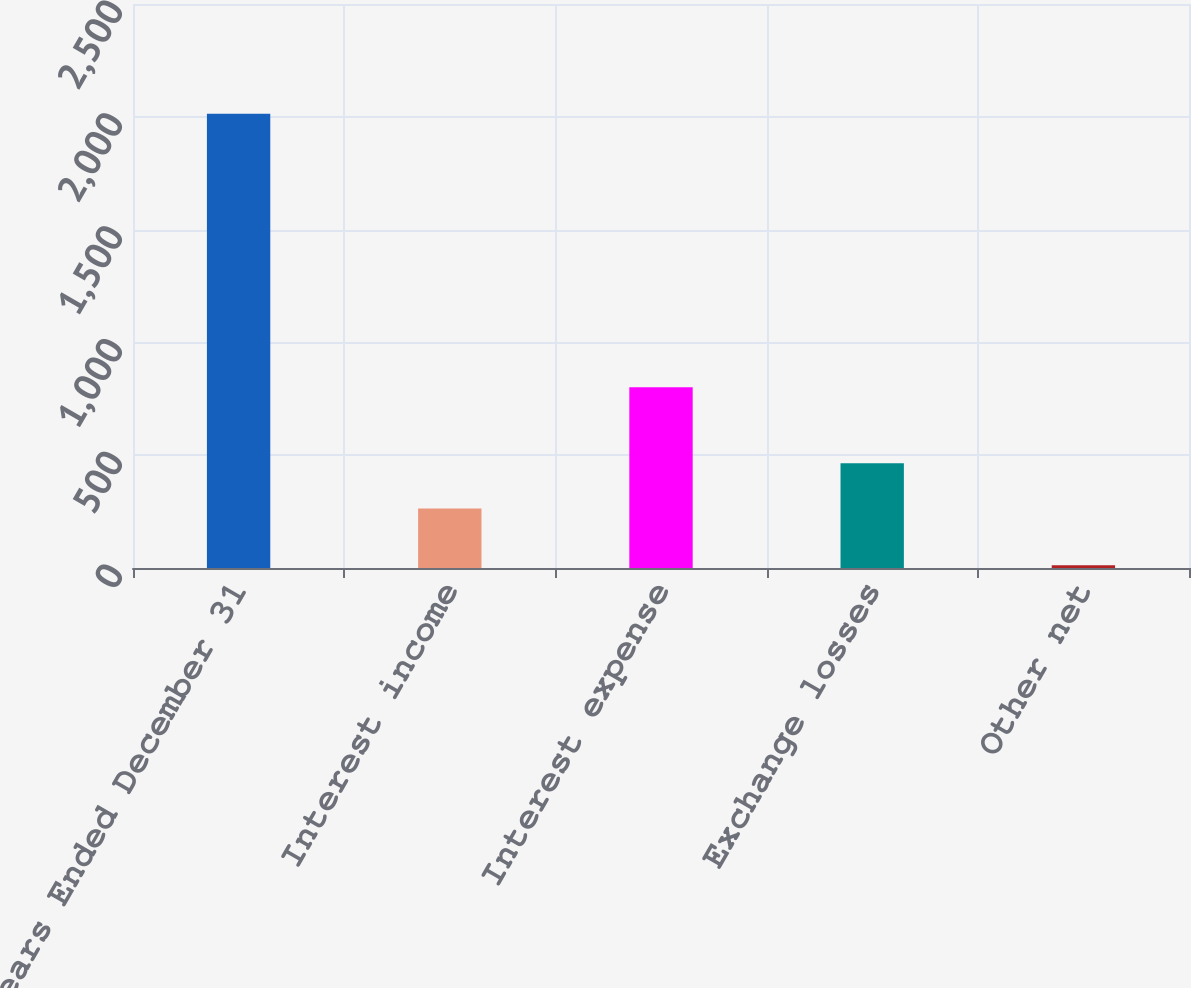Convert chart to OTSL. <chart><loc_0><loc_0><loc_500><loc_500><bar_chart><fcel>Years Ended December 31<fcel>Interest income<fcel>Interest expense<fcel>Exchange losses<fcel>Other net<nl><fcel>2013<fcel>264<fcel>801<fcel>464.1<fcel>12<nl></chart> 